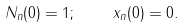<formula> <loc_0><loc_0><loc_500><loc_500>N _ { n } ( 0 ) = 1 ; \quad x _ { n } ( 0 ) = 0 .</formula> 